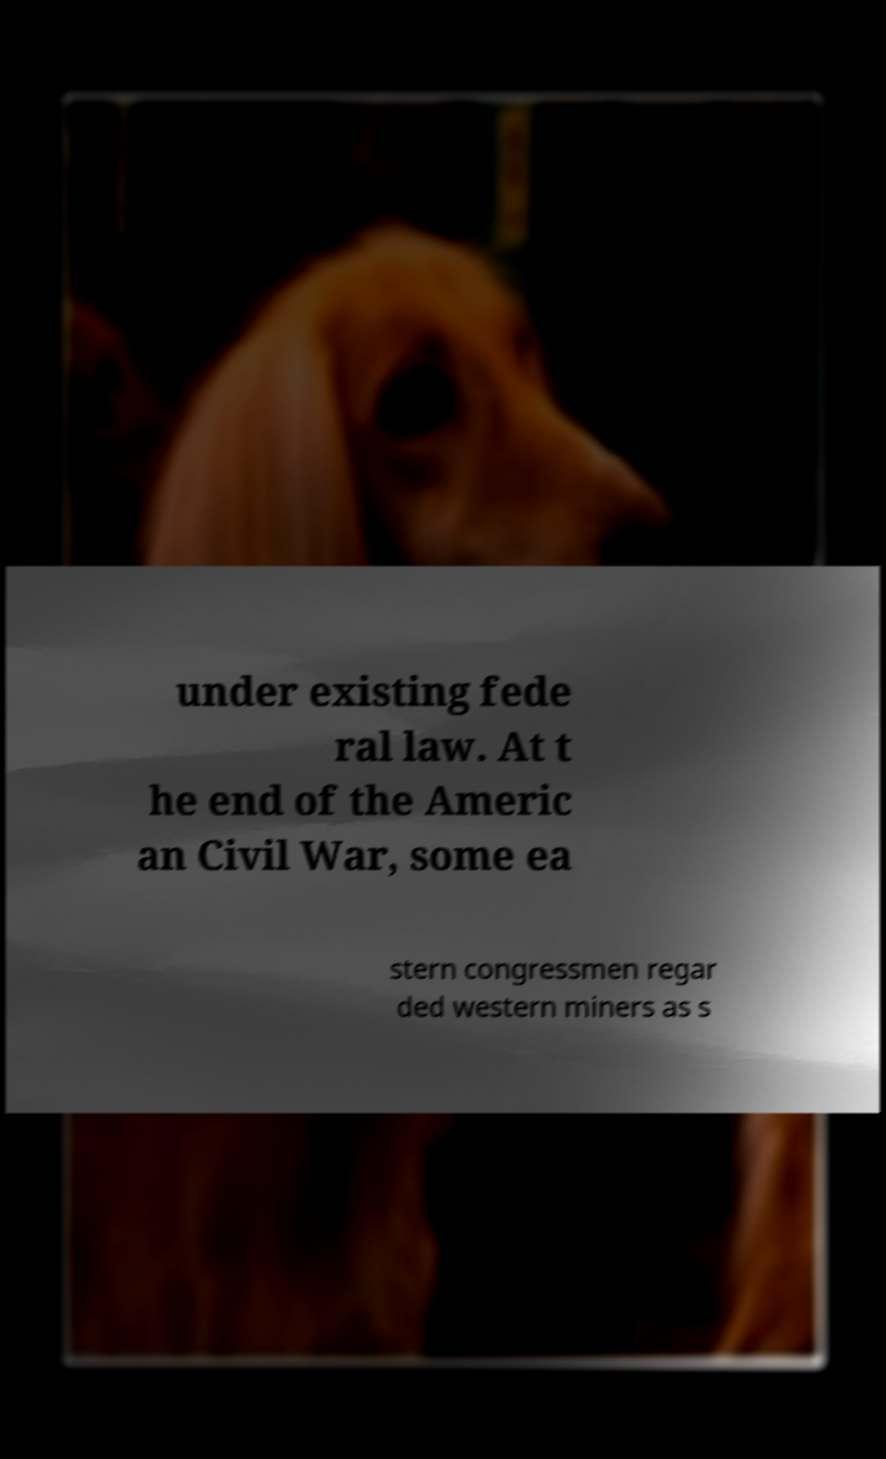What messages or text are displayed in this image? I need them in a readable, typed format. under existing fede ral law. At t he end of the Americ an Civil War, some ea stern congressmen regar ded western miners as s 